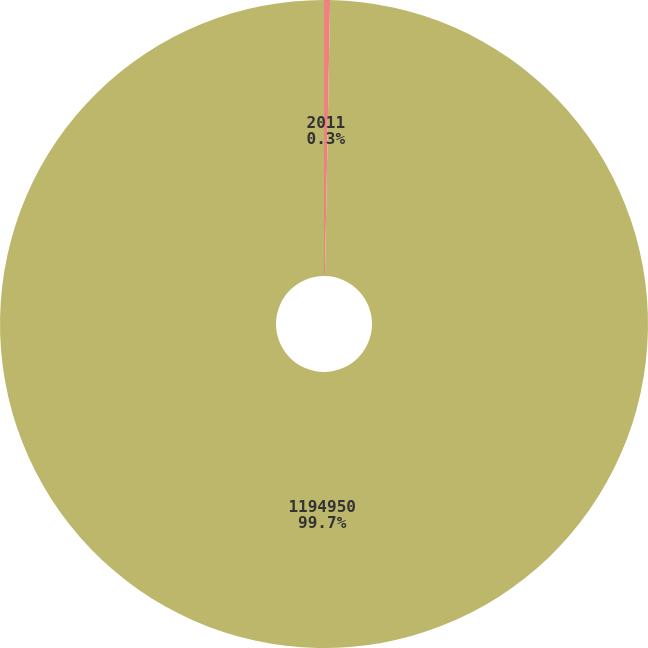<chart> <loc_0><loc_0><loc_500><loc_500><pie_chart><fcel>2011<fcel>1194950<nl><fcel>0.3%<fcel>99.7%<nl></chart> 